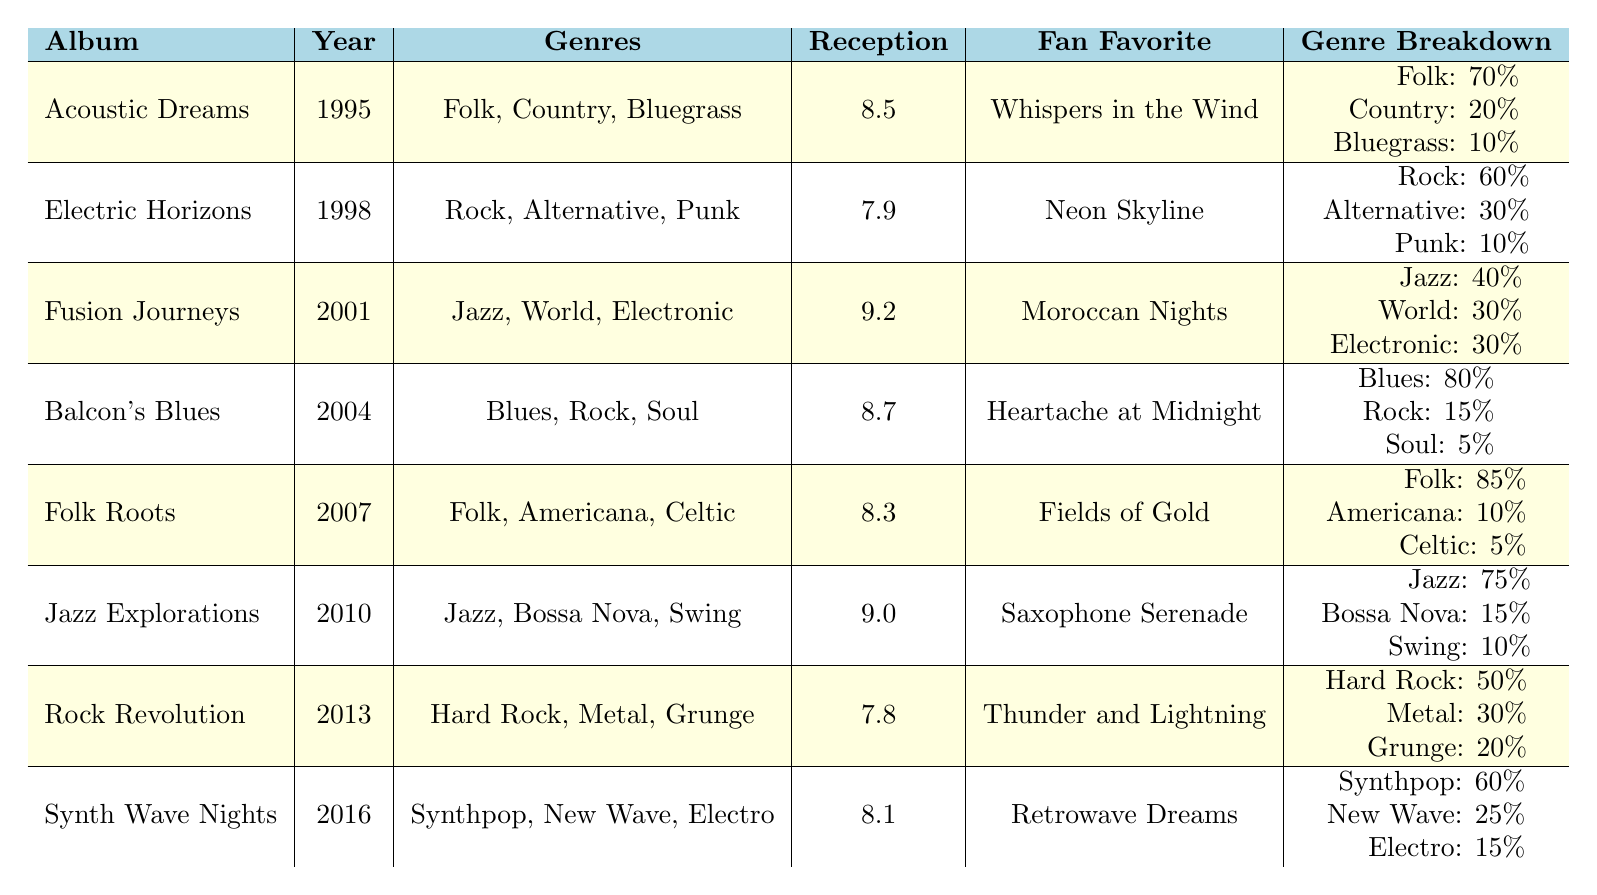What genre has the highest percentage in "Balcon's Blues"? The table shows that "Balcon's Blues" has a genre breakdown of Blues (80%), Rock (15%), and Soul (5%). Thus, Blues has the highest percentage.
Answer: Blues Which album was released in 2001? The table lists the album "Fusion Journeys" with a release year of 2001.
Answer: Fusion Journeys What is the fan favorite from "Acoustic Dreams"? The table directly states that the fan favorite song from "Acoustic Dreams" is "Whispers in the Wind."
Answer: Whispers in the Wind Which album has the lowest critical reception rating? By reviewing the critical reception ratings, "Rock Revolution" has the lowest rating at 7.8.
Answer: Rock Revolution What is the average critical reception rating of all albums? The critical reception ratings are 8.5, 7.9, 9.2, 8.7, 8.3, 9.0, 7.8, and 8.1. Adding them gives 70.5, and dividing by 8 results in an average of 8.8125.
Answer: 8.81 Is "Jazz Explorations" more favored by fans than "Rock Revolution"? The fan favorites show "Saxophone Serenade" for "Jazz Explorations" and "Thunder and Lightning" for "Rock Revolution." The critical reception rating for "Jazz Explorations" (9.0) is higher than "Rock Revolution" (7.8), indicating that it is indeed more favored.
Answer: Yes How does the genre breakdown of "Fusion Journeys" compare to "Jazz Explorations"? For "Fusion Journeys," the breakdown is Jazz (40%), World (30%), and Electronic (30%). "Jazz Explorations" has Jazz (75%), Bossa Nova (15%), and Swing (10%). The two albums share jazz but differ significantly in their other genres.
Answer: They differ significantly Which genre is most prominent in the album "Folk Roots"? The table indicates that in "Folk Roots," Folk comprises 85% of the genre breakdown, making it the most prominent genre.
Answer: Folk What percentage of genres in "Synth Wave Nights" is dedicated to Electro? The genre breakdown of "Synth Wave Nights" shows Electro at 15%, which is the percentage dedicated to this genre.
Answer: 15% Which album blends rock and alternative genres the most? "Electric Horizons" shows a genre breakdown of Rock (60%), Alternative (30%), and Punk (10%), making it the most blended album in these genres.
Answer: Electric Horizons 